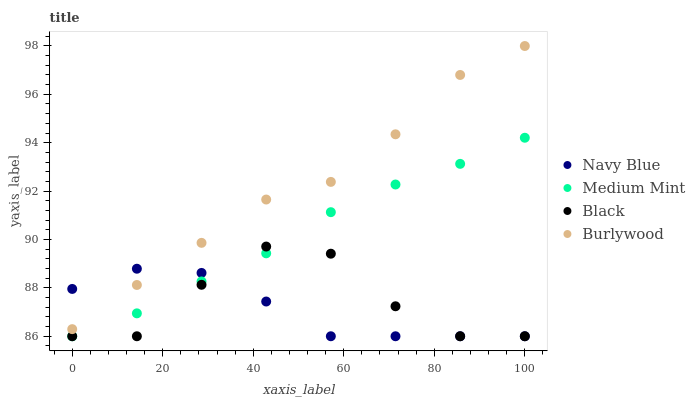Does Navy Blue have the minimum area under the curve?
Answer yes or no. Yes. Does Burlywood have the maximum area under the curve?
Answer yes or no. Yes. Does Black have the minimum area under the curve?
Answer yes or no. No. Does Black have the maximum area under the curve?
Answer yes or no. No. Is Medium Mint the smoothest?
Answer yes or no. Yes. Is Black the roughest?
Answer yes or no. Yes. Is Navy Blue the smoothest?
Answer yes or no. No. Is Navy Blue the roughest?
Answer yes or no. No. Does Medium Mint have the lowest value?
Answer yes or no. Yes. Does Burlywood have the lowest value?
Answer yes or no. No. Does Burlywood have the highest value?
Answer yes or no. Yes. Does Black have the highest value?
Answer yes or no. No. Is Black less than Burlywood?
Answer yes or no. Yes. Is Burlywood greater than Black?
Answer yes or no. Yes. Does Black intersect Navy Blue?
Answer yes or no. Yes. Is Black less than Navy Blue?
Answer yes or no. No. Is Black greater than Navy Blue?
Answer yes or no. No. Does Black intersect Burlywood?
Answer yes or no. No. 